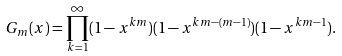<formula> <loc_0><loc_0><loc_500><loc_500>G _ { m } ( x ) & = \prod _ { k = 1 } ^ { \infty } ( 1 - x ^ { k m } ) ( 1 - x ^ { k m - ( m - 1 ) } ) ( 1 - x ^ { k m - 1 } ) .</formula> 